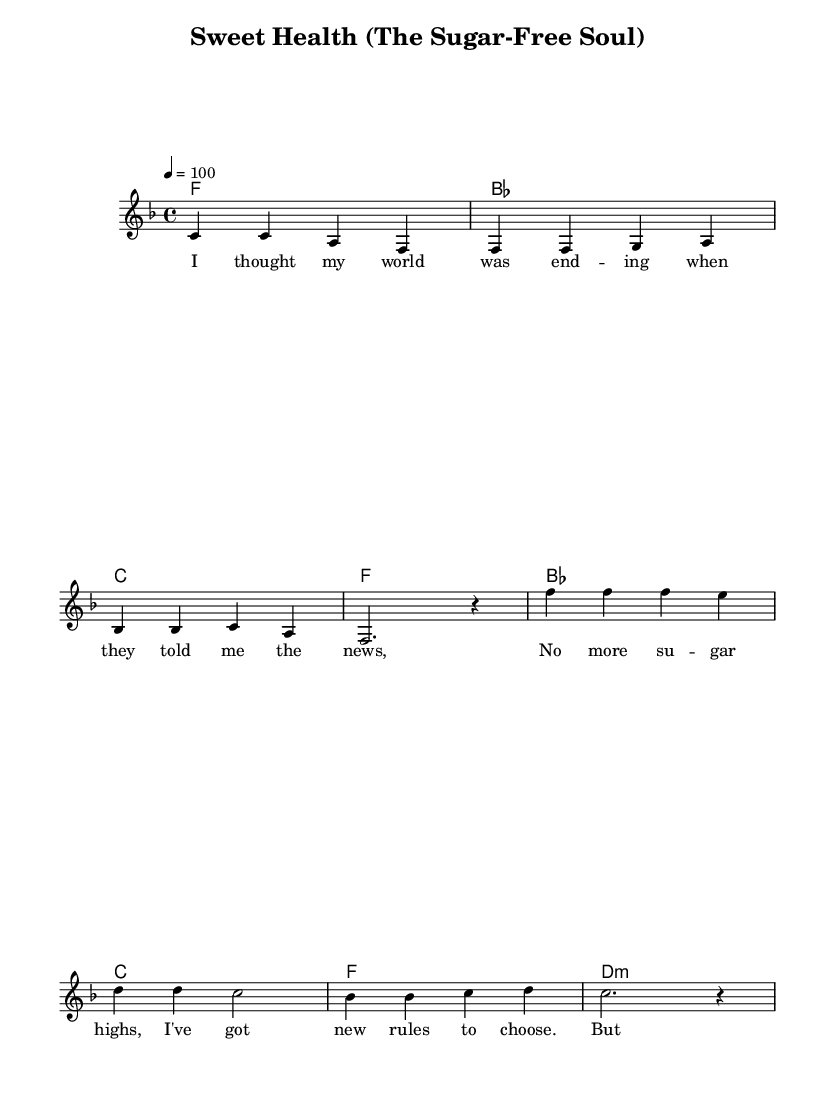What is the key signature of this music? The key signature is F major, which has one flat (B flat).
Answer: F major What is the time signature of the piece? The time signature is 4/4, indicating four beats per measure.
Answer: 4/4 What is the tempo marking for this music? The tempo marking is quarter note = 100, indicating the speed of the piece.
Answer: quarter note = 100 How many measures are in the verse section? There are 4 measures in the verse section, as indicated by the phrasing.
Answer: 4 What is the last chord played in the chorus? The last chord in the chorus is D minor, as shown in the chord progression.
Answer: D:m How many lyrics lines are there in the verse? There are 2 lines of lyrics in the verse, as we can see from the lyrical layout.
Answer: 2 Which theme is prominently celebrated in the song? The song celebrates health and self-care, focusing on the positive aspects of a sugar-free lifestyle.
Answer: health and self-care 